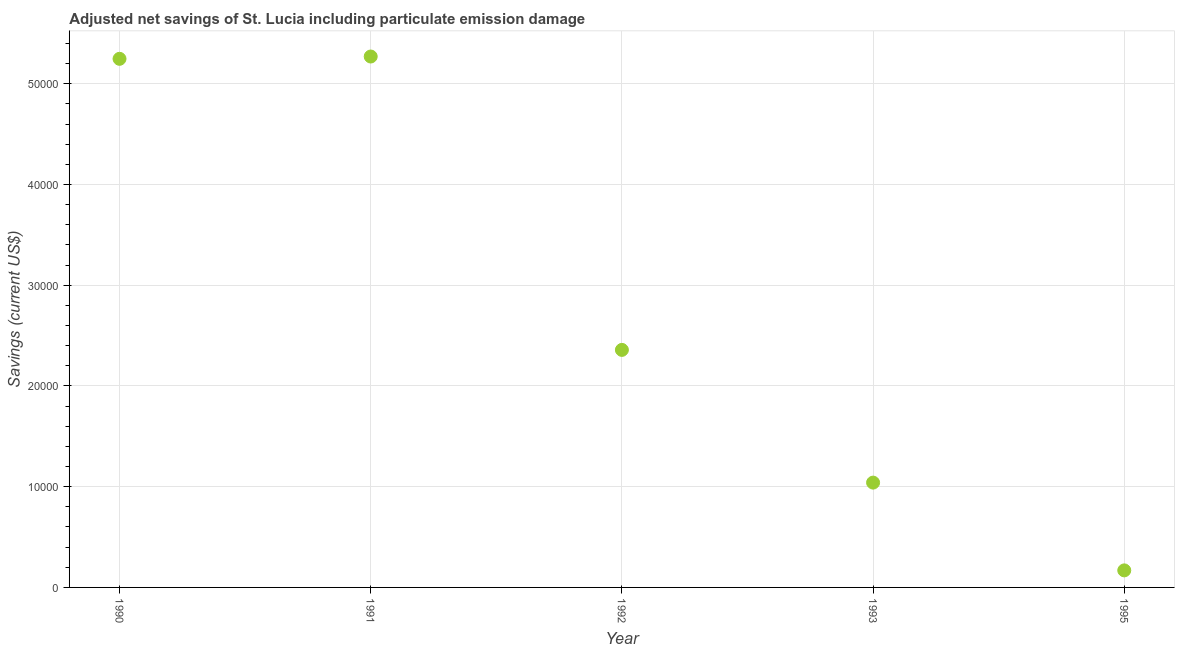What is the adjusted net savings in 1992?
Your answer should be compact. 2.36e+04. Across all years, what is the maximum adjusted net savings?
Provide a short and direct response. 5.27e+04. Across all years, what is the minimum adjusted net savings?
Make the answer very short. 1692.48. In which year was the adjusted net savings minimum?
Provide a succinct answer. 1995. What is the sum of the adjusted net savings?
Offer a very short reply. 1.41e+05. What is the difference between the adjusted net savings in 1991 and 1992?
Provide a succinct answer. 2.91e+04. What is the average adjusted net savings per year?
Ensure brevity in your answer.  2.82e+04. What is the median adjusted net savings?
Provide a succinct answer. 2.36e+04. Do a majority of the years between 1990 and 1993 (inclusive) have adjusted net savings greater than 2000 US$?
Provide a short and direct response. Yes. What is the ratio of the adjusted net savings in 1990 to that in 1995?
Provide a succinct answer. 31. Is the adjusted net savings in 1993 less than that in 1995?
Give a very brief answer. No. Is the difference between the adjusted net savings in 1990 and 1991 greater than the difference between any two years?
Your answer should be very brief. No. What is the difference between the highest and the second highest adjusted net savings?
Give a very brief answer. 228.94. What is the difference between the highest and the lowest adjusted net savings?
Your answer should be compact. 5.10e+04. Does the adjusted net savings monotonically increase over the years?
Offer a very short reply. No. How many dotlines are there?
Provide a short and direct response. 1. Are the values on the major ticks of Y-axis written in scientific E-notation?
Give a very brief answer. No. What is the title of the graph?
Ensure brevity in your answer.  Adjusted net savings of St. Lucia including particulate emission damage. What is the label or title of the X-axis?
Offer a terse response. Year. What is the label or title of the Y-axis?
Offer a terse response. Savings (current US$). What is the Savings (current US$) in 1990?
Keep it short and to the point. 5.25e+04. What is the Savings (current US$) in 1991?
Offer a terse response. 5.27e+04. What is the Savings (current US$) in 1992?
Your response must be concise. 2.36e+04. What is the Savings (current US$) in 1993?
Make the answer very short. 1.04e+04. What is the Savings (current US$) in 1995?
Offer a terse response. 1692.48. What is the difference between the Savings (current US$) in 1990 and 1991?
Keep it short and to the point. -228.94. What is the difference between the Savings (current US$) in 1990 and 1992?
Your answer should be compact. 2.89e+04. What is the difference between the Savings (current US$) in 1990 and 1993?
Keep it short and to the point. 4.21e+04. What is the difference between the Savings (current US$) in 1990 and 1995?
Ensure brevity in your answer.  5.08e+04. What is the difference between the Savings (current US$) in 1991 and 1992?
Make the answer very short. 2.91e+04. What is the difference between the Savings (current US$) in 1991 and 1993?
Your answer should be very brief. 4.23e+04. What is the difference between the Savings (current US$) in 1991 and 1995?
Your answer should be very brief. 5.10e+04. What is the difference between the Savings (current US$) in 1992 and 1993?
Ensure brevity in your answer.  1.32e+04. What is the difference between the Savings (current US$) in 1992 and 1995?
Offer a terse response. 2.19e+04. What is the difference between the Savings (current US$) in 1993 and 1995?
Provide a succinct answer. 8712.02. What is the ratio of the Savings (current US$) in 1990 to that in 1991?
Provide a short and direct response. 1. What is the ratio of the Savings (current US$) in 1990 to that in 1992?
Offer a terse response. 2.23. What is the ratio of the Savings (current US$) in 1990 to that in 1993?
Make the answer very short. 5.04. What is the ratio of the Savings (current US$) in 1990 to that in 1995?
Ensure brevity in your answer.  31. What is the ratio of the Savings (current US$) in 1991 to that in 1992?
Your answer should be very brief. 2.23. What is the ratio of the Savings (current US$) in 1991 to that in 1993?
Your answer should be compact. 5.07. What is the ratio of the Savings (current US$) in 1991 to that in 1995?
Your response must be concise. 31.14. What is the ratio of the Savings (current US$) in 1992 to that in 1993?
Provide a succinct answer. 2.27. What is the ratio of the Savings (current US$) in 1992 to that in 1995?
Your response must be concise. 13.93. What is the ratio of the Savings (current US$) in 1993 to that in 1995?
Offer a terse response. 6.15. 